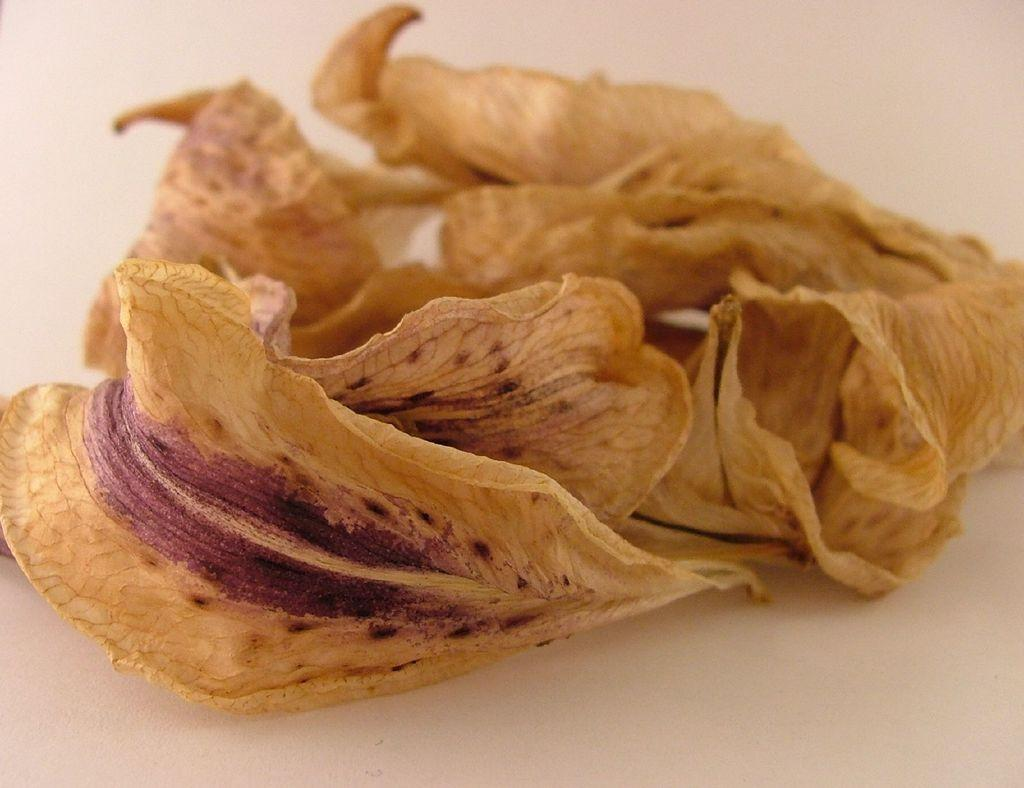What type of natural material can be seen in the image? There are dry leaves in the image. What is the color of the surface on which the leaves are placed? The surface on which the leaves are placed is white. What type of bone can be seen in the image? There is no bone present in the image; it only features dry leaves on a white surface. 